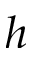Convert formula to latex. <formula><loc_0><loc_0><loc_500><loc_500>h</formula> 